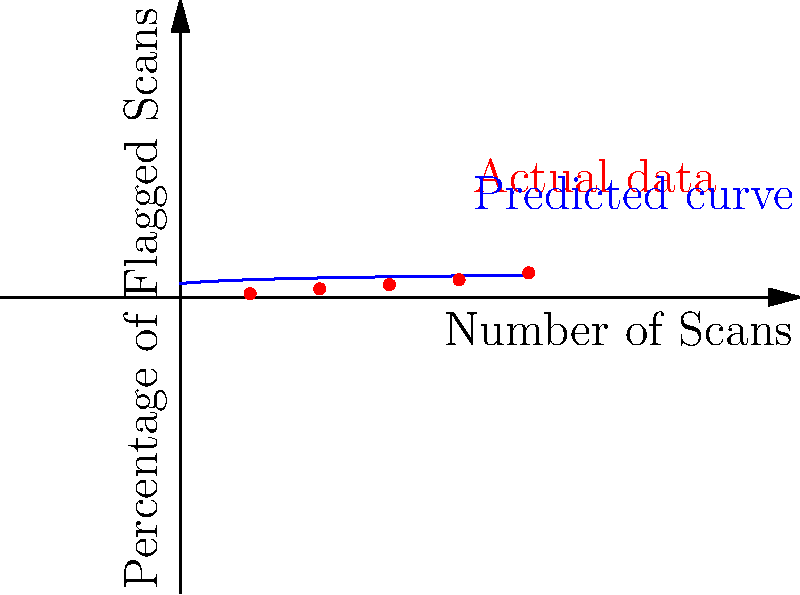As a healthcare insider exposing fraudulent practices, you've analyzed the relationship between the number of medical imaging scans performed and the percentage of scans flagged for potential fraud or unnecessary procedures. The graph shows actual data points and a predicted curve. Which mathematical function best describes the relationship between the number of scans and the percentage of flagged scans? To determine the best mathematical function that describes the relationship, let's analyze the graph step-by-step:

1. Observe the shape of the curve: It starts with a steep increase and then gradually levels off as the number of scans increases.

2. Note that the y-axis (percentage of flagged scans) doesn't increase linearly with the x-axis (number of scans).

3. The curve appears to be concave down, meaning its rate of increase is slowing as x increases.

4. This pattern is characteristic of a logarithmic function, which can be expressed as $y = a \ln(x + b) + c$, where $a$, $b$, and $c$ are constants.

5. The blue curve in the graph closely resembles a logarithmic function.

6. Other common functions like linear ($y = mx + b$), exponential ($y = ae^{bx}$), or power functions ($y = ax^b$) don't fit the observed pattern as well.

7. A logarithmic function makes sense in this context because:
   - As the number of scans increases, the percentage of flagged scans is likely to increase, but at a decreasing rate.
   - There's likely an upper limit to the percentage of scans that can be flagged, which a logarithmic function approaches asymptotically.

Therefore, the best mathematical function to describe this relationship is a logarithmic function.
Answer: Logarithmic function 